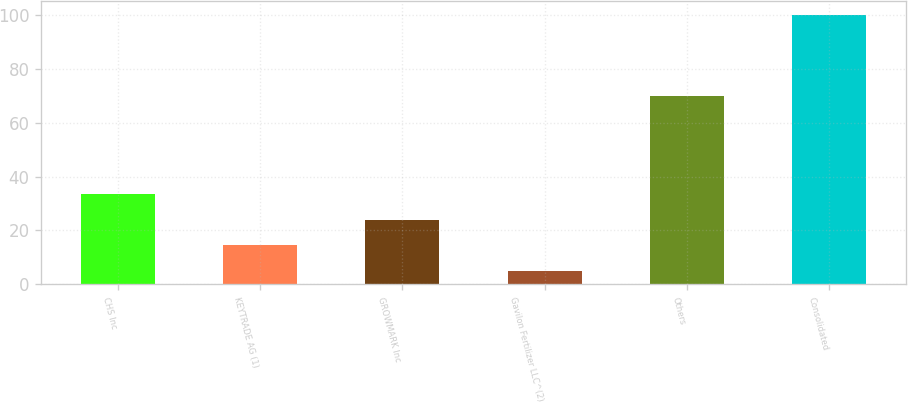Convert chart to OTSL. <chart><loc_0><loc_0><loc_500><loc_500><bar_chart><fcel>CHS Inc<fcel>KEYTRADE AG (1)<fcel>GROWMARK Inc<fcel>Gavilon Fertilizer LLC^(2)<fcel>Others<fcel>Consolidated<nl><fcel>33.5<fcel>14.5<fcel>24<fcel>5<fcel>70<fcel>100<nl></chart> 